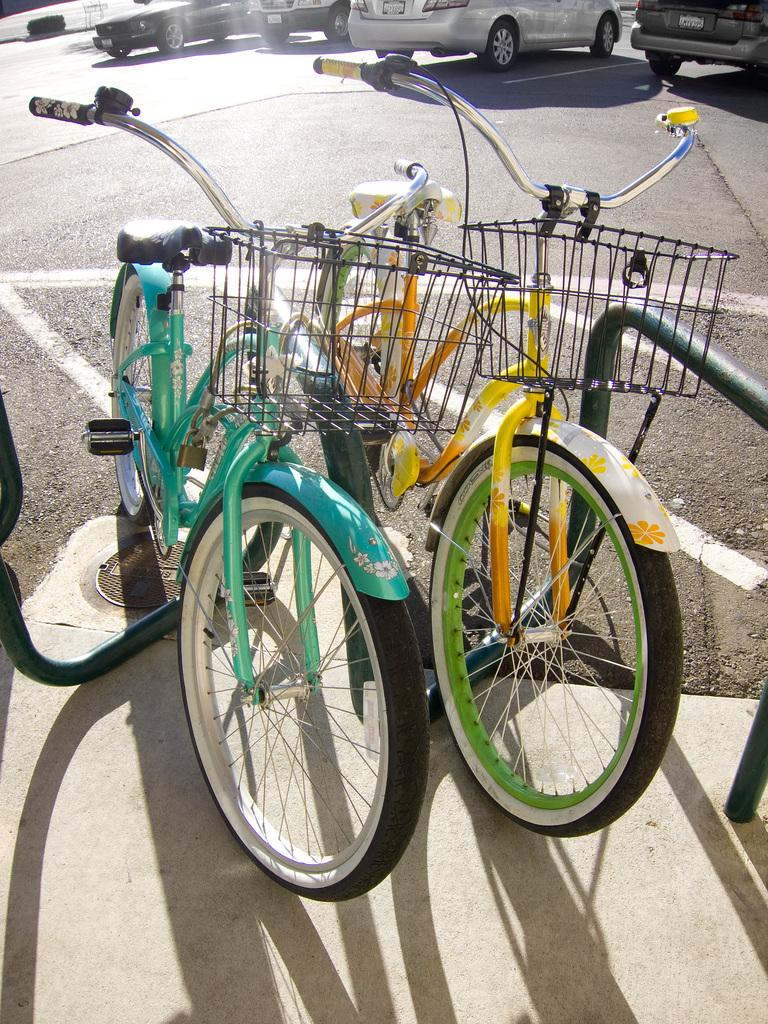What type of transportation can be seen in the image? There are bicycles parked in the image. What is located beside the bicycles? There is a metal structure beside the bicycles. What else can be seen in the background of the image? There are vehicles parked on the road in the background of the image. What type of collar is visible on the bicycles in the image? There are no collars present on the bicycles in the image. How does the motion of the bicycles change throughout the day in the image? The image is a still photograph, so the motion of the bicycles does not change throughout the day. 